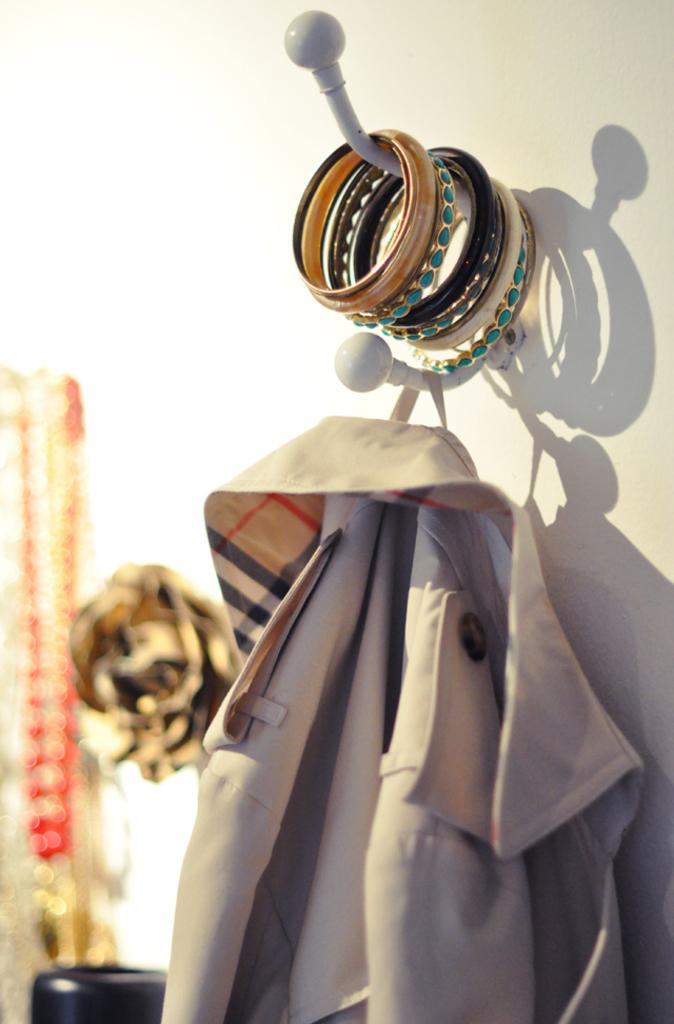What is the main subject in the middle of the image? There is a dress in the middle of the image. What can be seen on the left side of the image? There is a chain on the left side of the image. What type of jewelry is visible at the top of the image? There are bangles at the top of the image. How does the dress express disgust in the image? The dress does not express any emotion, including disgust, in the image. It is an inanimate object and cannot display emotions. 